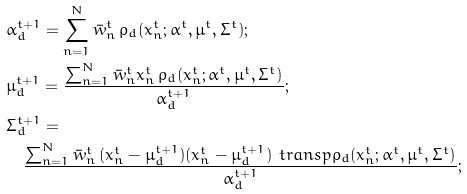<formula> <loc_0><loc_0><loc_500><loc_500>& \alpha ^ { t + 1 } _ { d } = \sum _ { n = 1 } ^ { N } \bar { w } _ { n } ^ { t } \, \rho _ { d } ( x _ { n } ^ { t } ; \alpha ^ { t } , \mu ^ { t } , \Sigma ^ { t } ) ; \\ & \mu ^ { t + 1 } _ { d } = \frac { \sum _ { n = 1 } ^ { N } \bar { w } _ { n } ^ { t } x _ { n } ^ { t } \, \rho _ { d } ( x _ { n } ^ { t } ; \alpha ^ { t } , \mu ^ { t } , \Sigma ^ { t } ) } { \alpha ^ { t + 1 } _ { d } } ; \\ & \Sigma ^ { t + 1 } _ { d } = \\ & \quad \frac { \sum _ { n = 1 } ^ { N } \bar { w } _ { n } ^ { t } \, ( x _ { n } ^ { t } - \mu ^ { t + 1 } _ { d } ) ( x _ { n } ^ { t } - \mu ^ { t + 1 } _ { d } ) ^ { \ } t r a n s p \rho _ { d } ( x _ { n } ^ { t } ; \alpha ^ { t } , \mu ^ { t } , \Sigma ^ { t } ) } { \alpha ^ { t + 1 } _ { d } } ;</formula> 